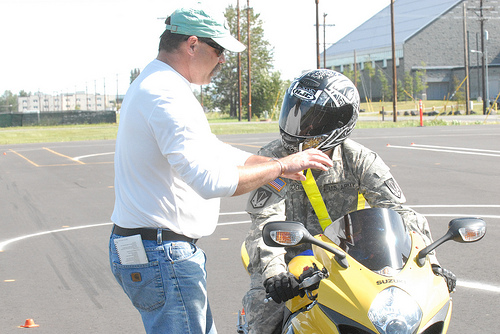<image>
Can you confirm if the helmet is on the man? Yes. Looking at the image, I can see the helmet is positioned on top of the man, with the man providing support. Is the man on the motorcycle? No. The man is not positioned on the motorcycle. They may be near each other, but the man is not supported by or resting on top of the motorcycle. Is there a man behind the bike? No. The man is not behind the bike. From this viewpoint, the man appears to be positioned elsewhere in the scene. 